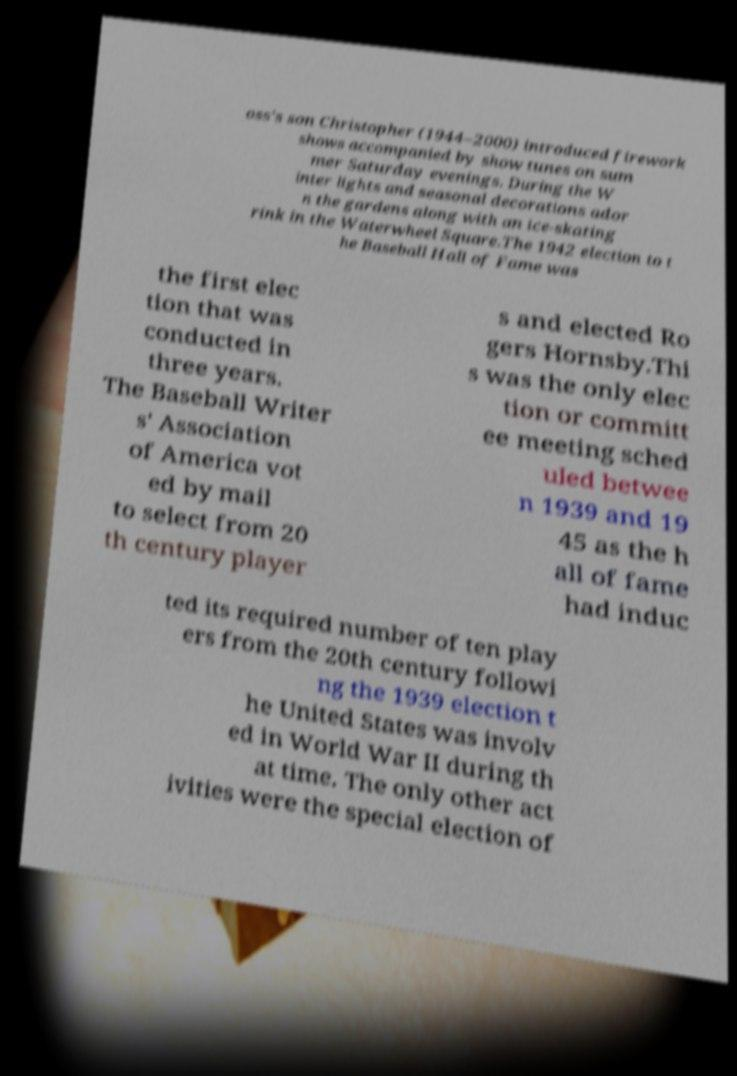Can you read and provide the text displayed in the image?This photo seems to have some interesting text. Can you extract and type it out for me? oss's son Christopher (1944–2000) introduced firework shows accompanied by show tunes on sum mer Saturday evenings. During the W inter lights and seasonal decorations ador n the gardens along with an ice-skating rink in the Waterwheel Square.The 1942 election to t he Baseball Hall of Fame was the first elec tion that was conducted in three years. The Baseball Writer s' Association of America vot ed by mail to select from 20 th century player s and elected Ro gers Hornsby.Thi s was the only elec tion or committ ee meeting sched uled betwee n 1939 and 19 45 as the h all of fame had induc ted its required number of ten play ers from the 20th century followi ng the 1939 election t he United States was involv ed in World War II during th at time. The only other act ivities were the special election of 